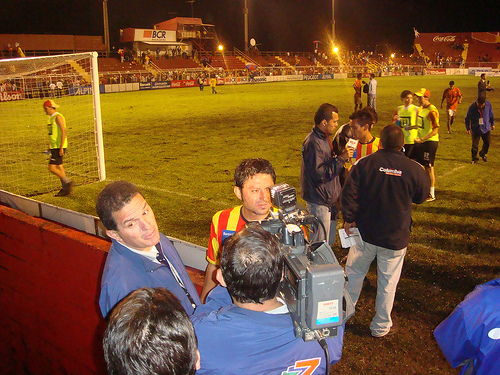<image>
Is the soccer goal above the camera man? No. The soccer goal is not positioned above the camera man. The vertical arrangement shows a different relationship. 